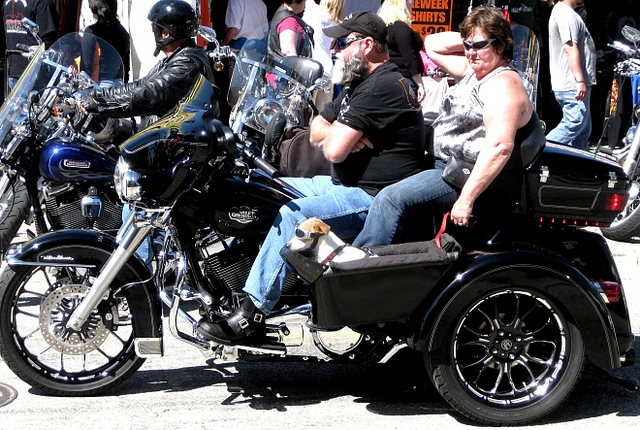Please identify all text content in this image. WEEK SHIRTS 20 